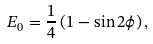Convert formula to latex. <formula><loc_0><loc_0><loc_500><loc_500>E _ { 0 } = \frac { 1 } { 4 } \left ( 1 - \sin 2 \phi \right ) ,</formula> 